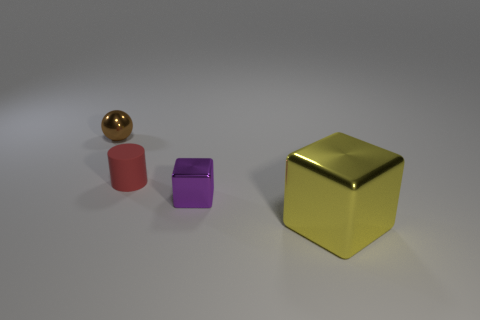Add 3 big spheres. How many objects exist? 7 Subtract all cylinders. How many objects are left? 3 Subtract all brown blocks. Subtract all tiny brown objects. How many objects are left? 3 Add 3 brown shiny balls. How many brown shiny balls are left? 4 Add 3 tiny brown matte objects. How many tiny brown matte objects exist? 3 Subtract 1 brown spheres. How many objects are left? 3 